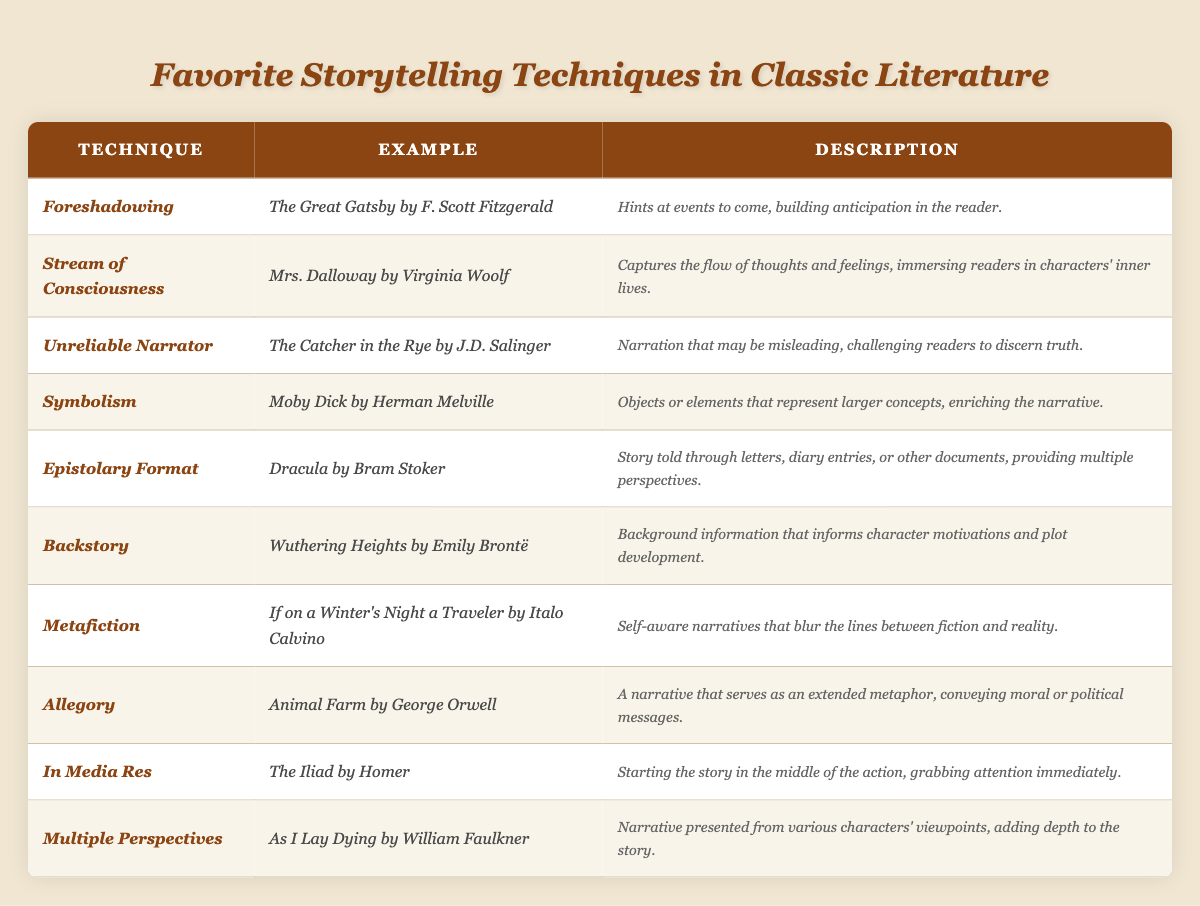What is the storytelling technique used in _The Great Gatsby_? The technique used in _The Great Gatsby_ is _foreshadowing_. This can be found directly in the "Technique" column corresponding to the example provided in the table.
Answer: Foreshadowing Which classic novel employs the _stream of consciousness_ technique? The novel that employs the _stream of consciousness_ technique is _Mrs. Dalloway_ by Virginia Woolf, as indicated in the "Example" column of the table.
Answer: _Mrs. Dalloway_ Is _The Catcher in the Rye_ known for using an unreliable narrator? Yes, _The Catcher in the Rye_ is known for using an unreliable narrator, as stated in its description in the table.
Answer: Yes How are the techniques of _symbolism_ and _allegory_ different in their descriptions? _Symbolism_ describes objects representing larger concepts, while _allegory_ conveys moral or political messages through an extended metaphor. The differences can be observed in their respective descriptions in the table.
Answer: Symbolism represents concepts; allegory conveys messages What is the only technique represented with a self-referential style? The technique with a self-referential style is _metafiction_, specifically mentioned in the example of _If on a Winter's Night a Traveler_. The description in the table supports this identification.
Answer: Metafiction List all techniques that involve inner thoughts of characters. The techniques involving inner thoughts of characters include _Stream of Consciousness_ and _Unreliable Narrator_. To find these, one can refer to their descriptions in the table which emphasize character introspection.
Answer: Stream of Consciousness, Unreliable Narrator Which technique is first alphabetically in the table? The first technique alphabetically in the table is _Allegory_. This can be found by looking through the "Technique" column and identifying the first entry based on alphabetical order.
Answer: Allegory How many storytelling techniques have corresponding examples from female authors? There are three techniques with examples from female authors:  _stream of consciousness_ (_Mrs. Dalloway_), _backstory_ (_Wuthering Heights_), and _epistolary format_ (_Dracula_). This conclusion is derived by counting the entries linked to female authors in the "Example" column.
Answer: Three Identify the technique that starts a story in the middle of action. The technique that starts a story in the middle of action is _In Media Res_. This is directly indicated alongside the example of _The Iliad_ in the table.
Answer: In Media Res What is the connection between _Wuthering Heights_ and character motivation according to the table? The connection is that _Wuthering Heights_ involves the technique of _backstory_, which provides background information that informs character motivations and plot developments, as explained in the table.
Answer: Backstory informs character motivation 